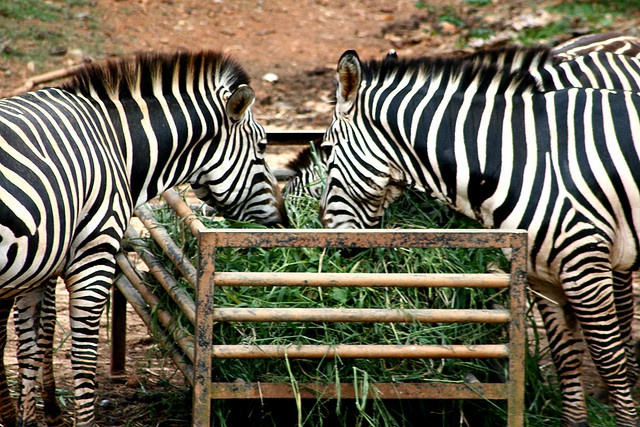Describe the objects in this image and their specific colors. I can see zebra in darkgreen, black, white, darkblue, and gray tones, zebra in darkgreen, black, ivory, gray, and darkgray tones, and zebra in darkgreen, black, ivory, and gray tones in this image. 